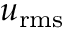Convert formula to latex. <formula><loc_0><loc_0><loc_500><loc_500>u _ { r m s }</formula> 